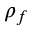<formula> <loc_0><loc_0><loc_500><loc_500>\rho _ { f }</formula> 